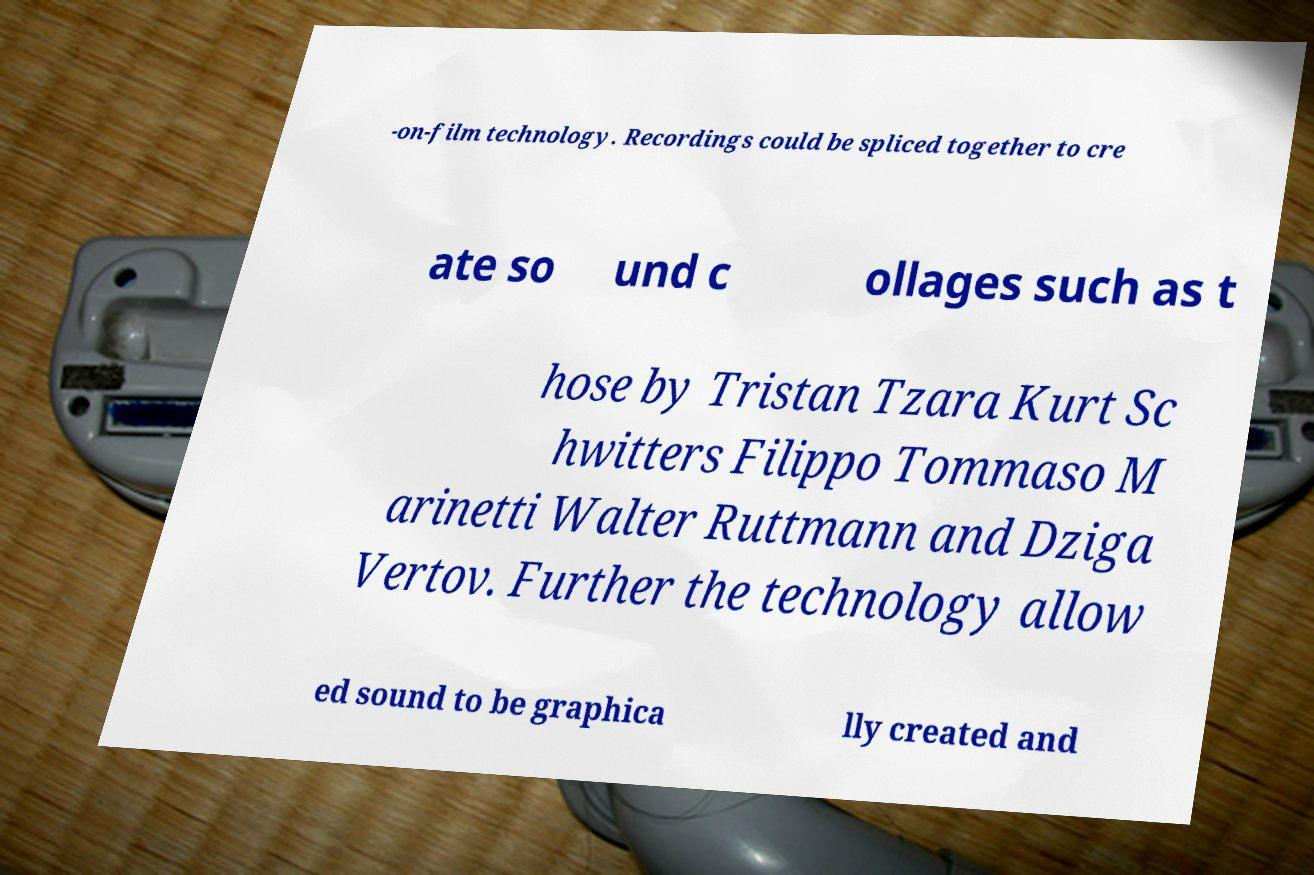What messages or text are displayed in this image? I need them in a readable, typed format. -on-film technology. Recordings could be spliced together to cre ate so und c ollages such as t hose by Tristan Tzara Kurt Sc hwitters Filippo Tommaso M arinetti Walter Ruttmann and Dziga Vertov. Further the technology allow ed sound to be graphica lly created and 